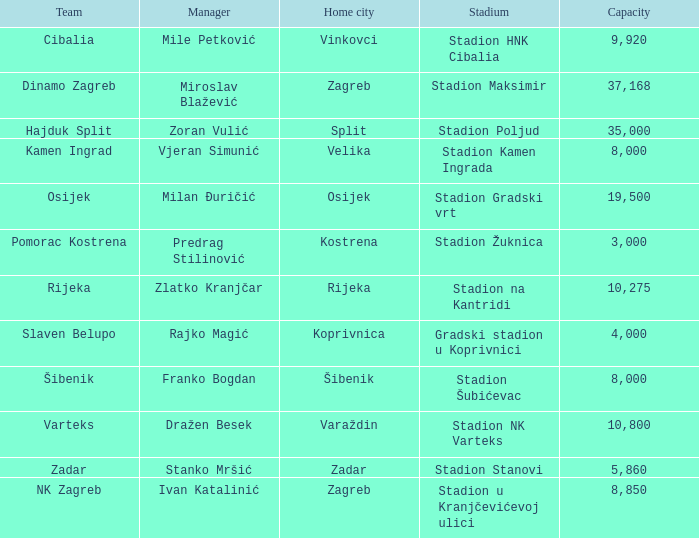What team has a home city of Koprivnica? Slaven Belupo. 